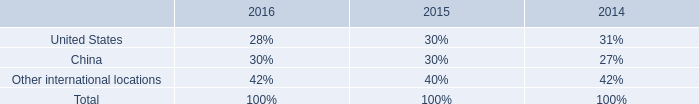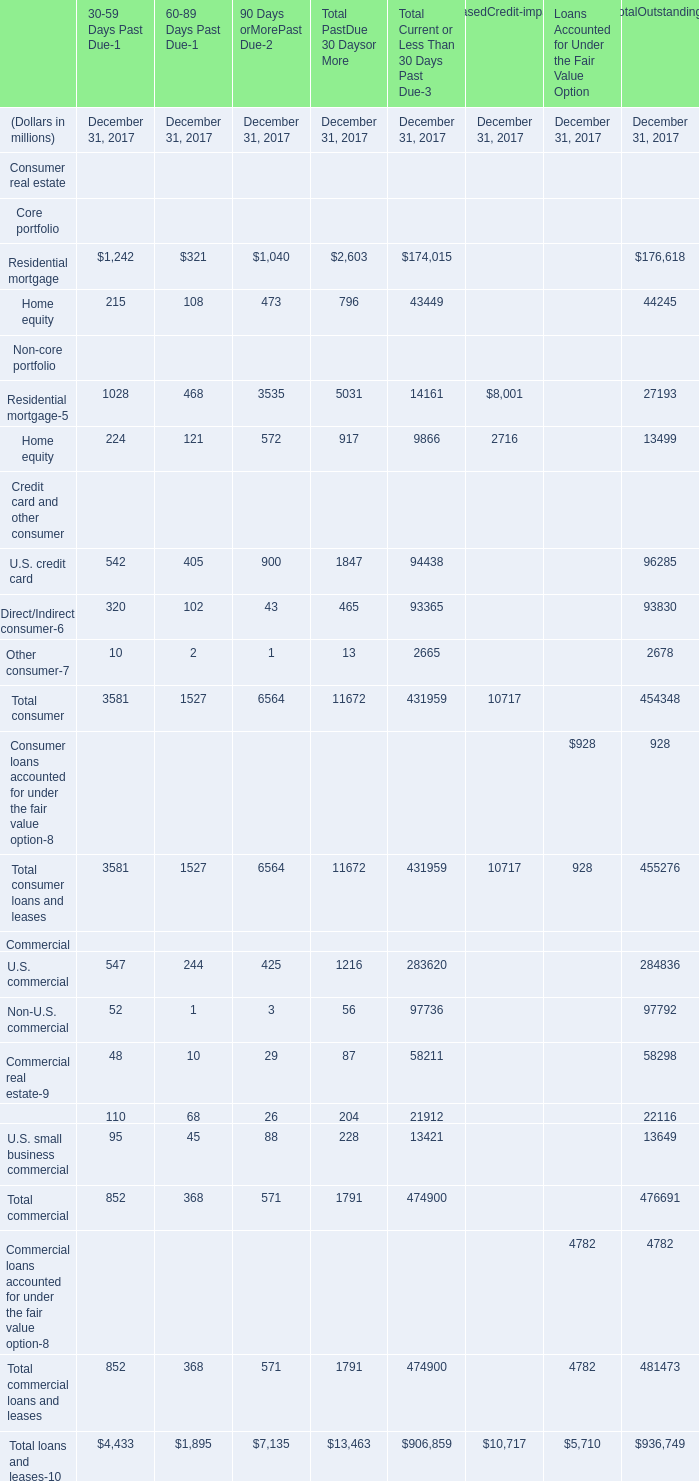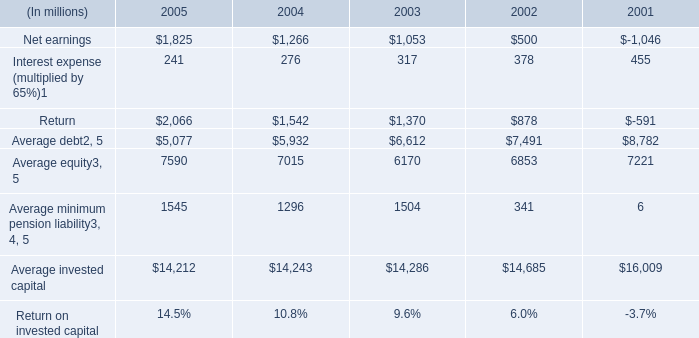what was the percentage of the taxes based on the based on the earnings from continuing operations before and after tax in the md&a 
Computations: ((173 - 113) / 173)
Answer: 0.34682. 